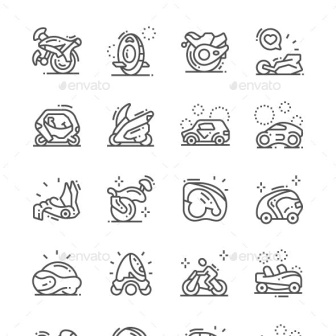Which icon represents a mode of transportation typically used in extreme conditions? The icons representing a snowmobile and a rocket are typically associated with extreme conditions. The snowmobile is commonly used in snowy, icy environments, while the rocket is utilized for space travel, which is arguably one of the most extreme conditions humans can experience. 